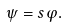<formula> <loc_0><loc_0><loc_500><loc_500>\psi = s \varphi .</formula> 